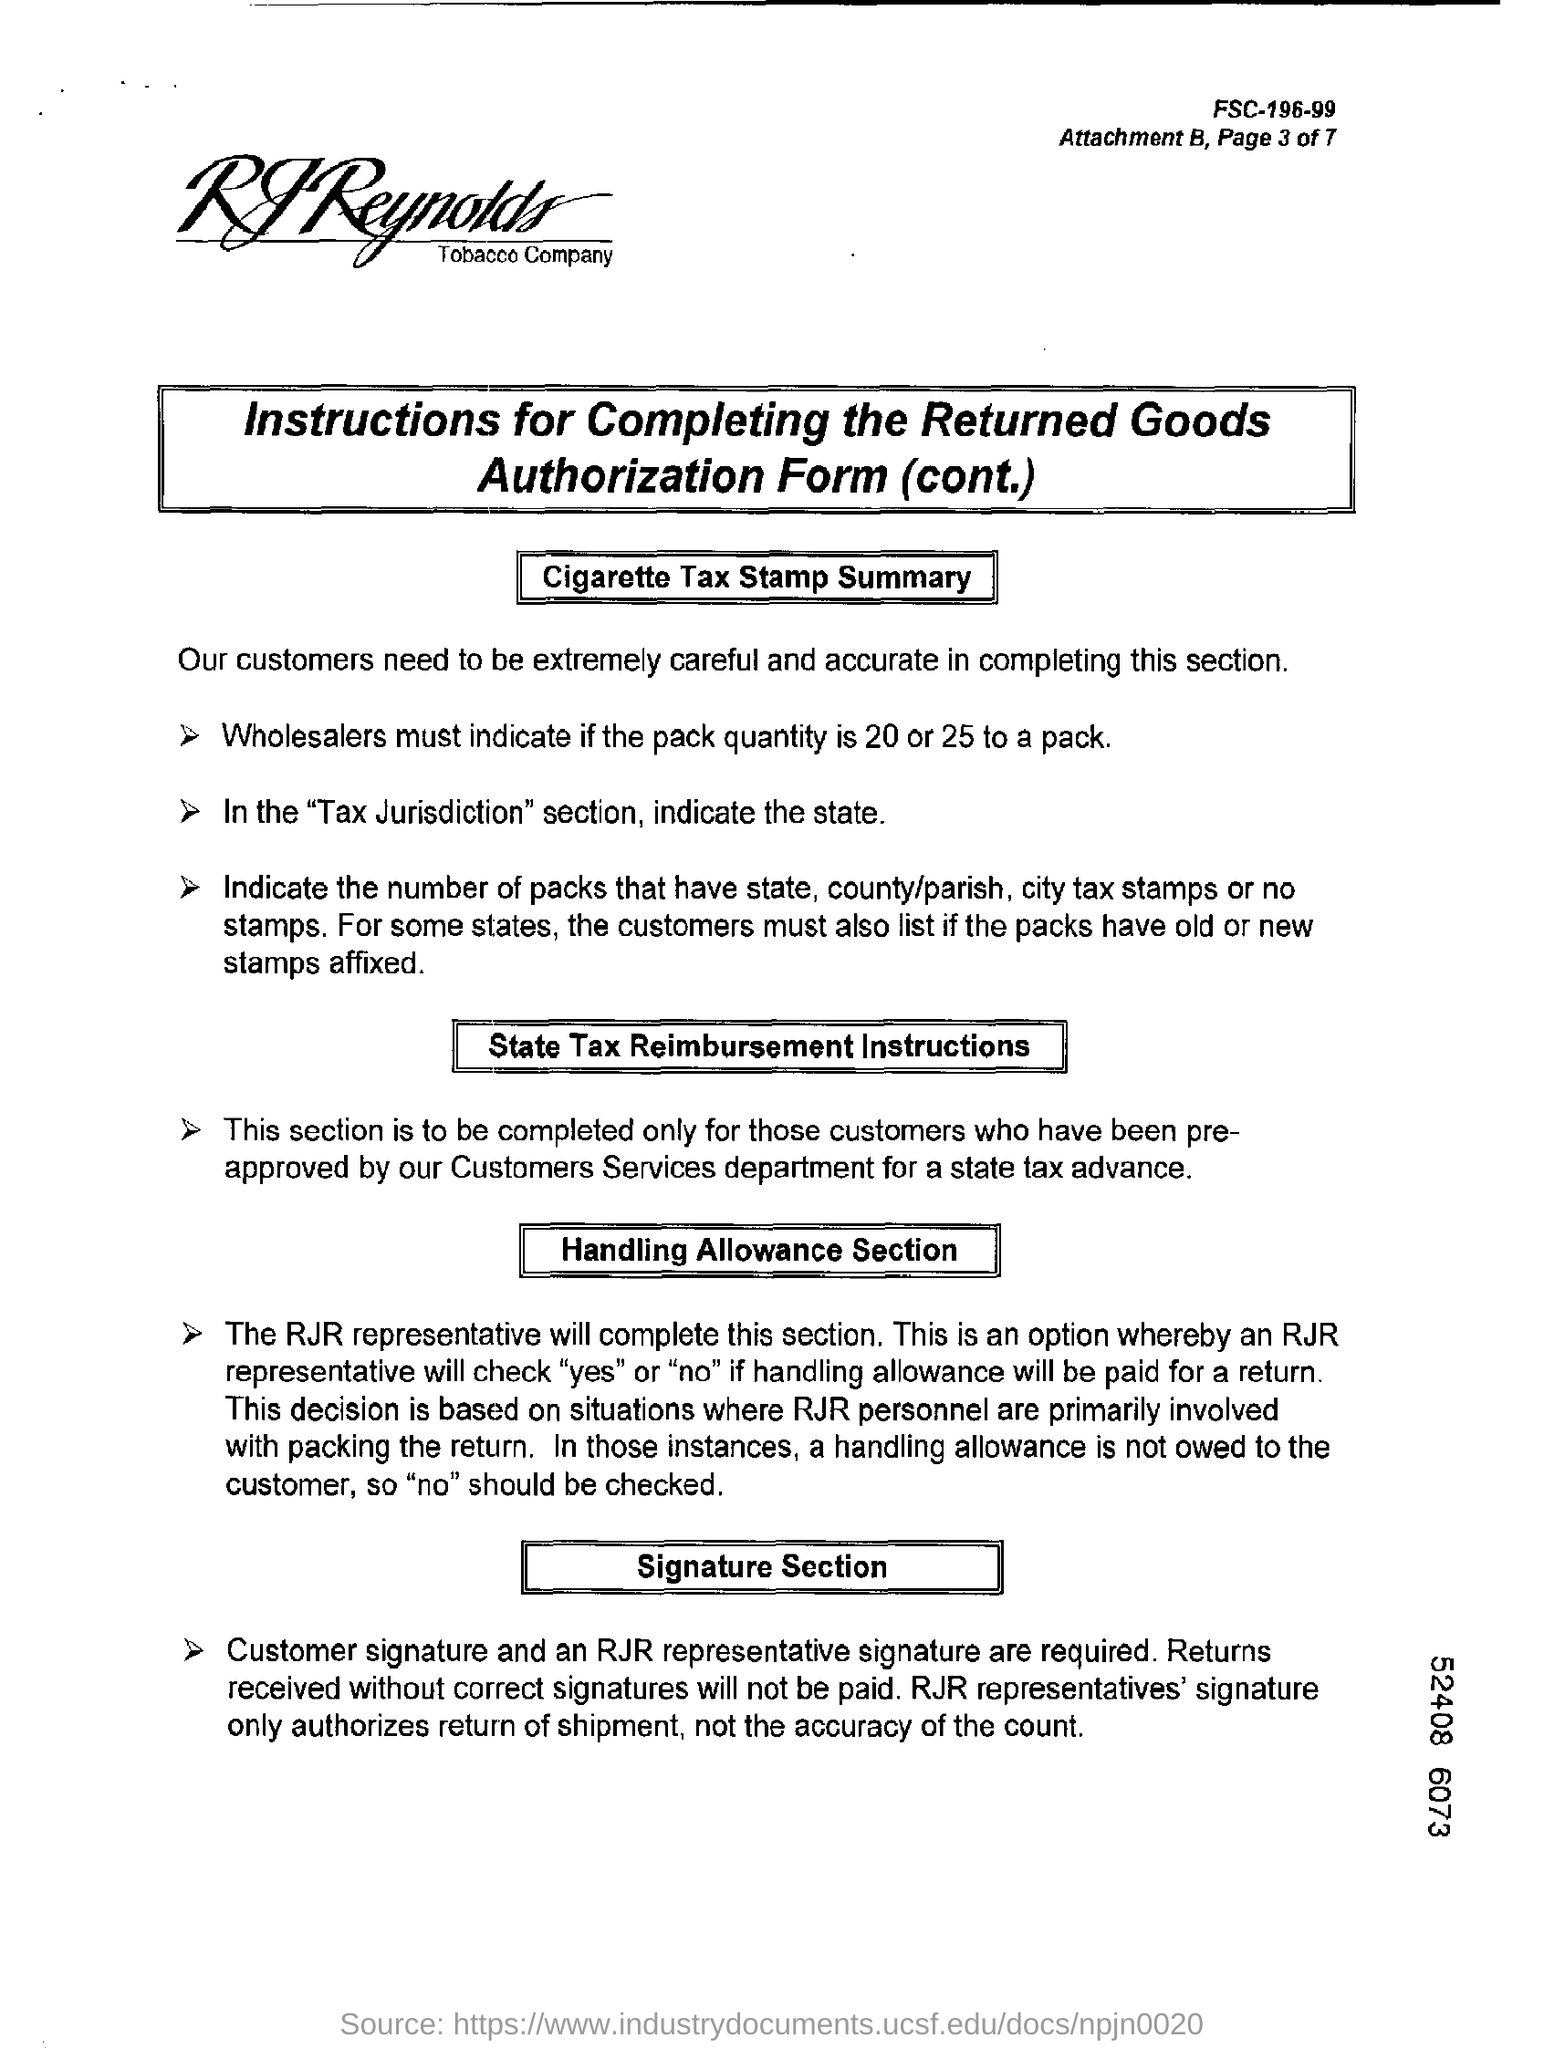List a handful of essential elements in this visual. The completion of the Handling Allowance section will be handled by a representative of RJR. The customer's signature and the signature of a representative of RJR are required in the signature section. It is recommended that the state should be indicated in the "Tax Jurisdiction" section. RJR Representatives' signature authorizes the return of a shipment. 